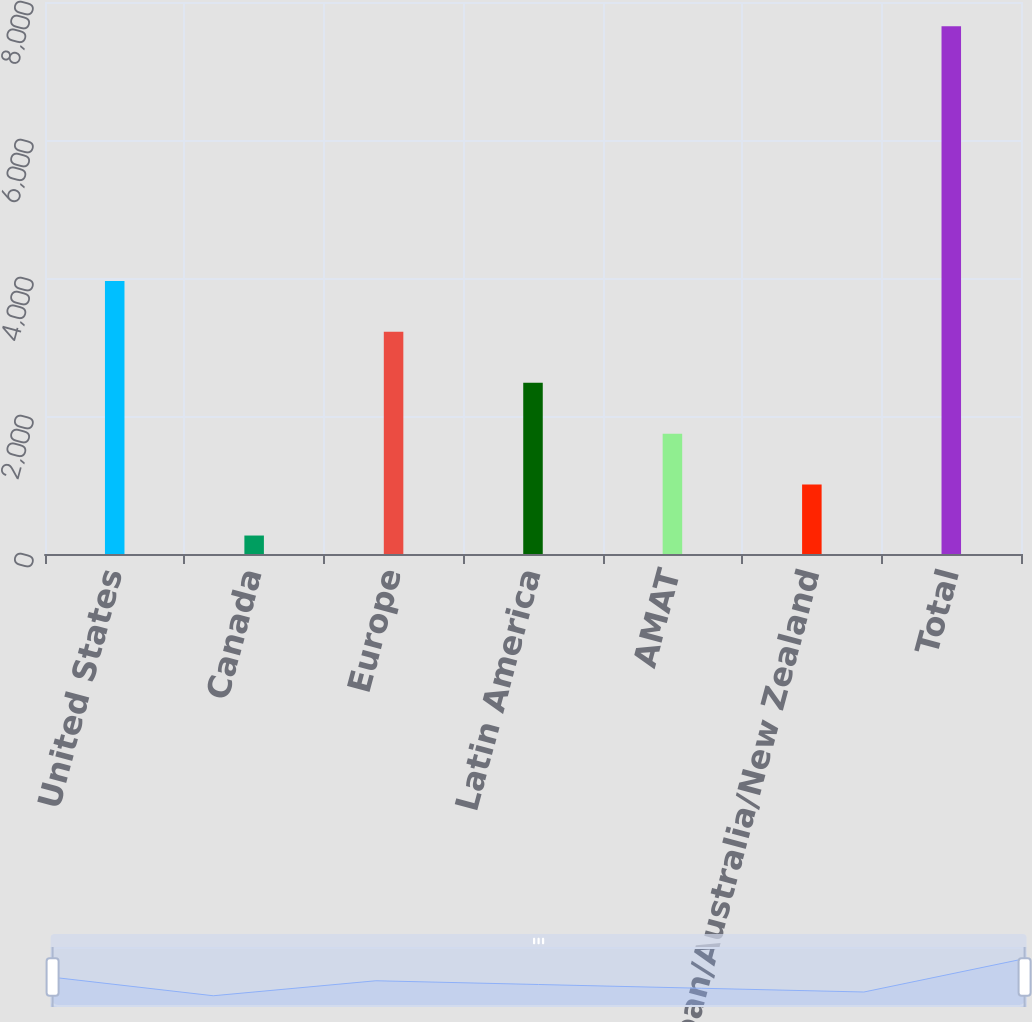Convert chart. <chart><loc_0><loc_0><loc_500><loc_500><bar_chart><fcel>United States<fcel>Canada<fcel>Europe<fcel>Latin America<fcel>AMAT<fcel>Japan/Australia/New Zealand<fcel>Total<nl><fcel>3957.9<fcel>267.7<fcel>3219.86<fcel>2481.82<fcel>1743.78<fcel>1005.74<fcel>7648.1<nl></chart> 